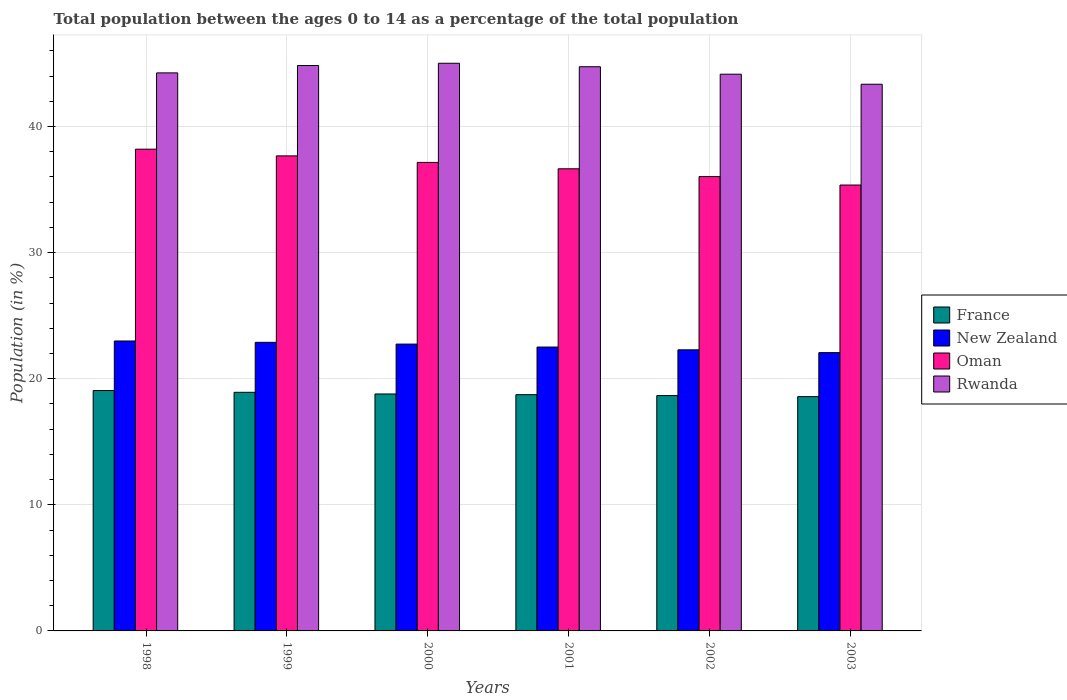How many different coloured bars are there?
Offer a terse response. 4. Are the number of bars on each tick of the X-axis equal?
Provide a succinct answer. Yes. What is the label of the 5th group of bars from the left?
Your response must be concise. 2002. What is the percentage of the population ages 0 to 14 in Oman in 1999?
Offer a very short reply. 37.67. Across all years, what is the maximum percentage of the population ages 0 to 14 in France?
Provide a short and direct response. 19.06. Across all years, what is the minimum percentage of the population ages 0 to 14 in France?
Keep it short and to the point. 18.58. In which year was the percentage of the population ages 0 to 14 in Oman maximum?
Make the answer very short. 1998. What is the total percentage of the population ages 0 to 14 in Rwanda in the graph?
Ensure brevity in your answer.  266.35. What is the difference between the percentage of the population ages 0 to 14 in France in 1998 and that in 2003?
Offer a terse response. 0.48. What is the difference between the percentage of the population ages 0 to 14 in New Zealand in 2000 and the percentage of the population ages 0 to 14 in France in 1998?
Provide a short and direct response. 3.68. What is the average percentage of the population ages 0 to 14 in France per year?
Provide a succinct answer. 18.79. In the year 2001, what is the difference between the percentage of the population ages 0 to 14 in New Zealand and percentage of the population ages 0 to 14 in France?
Offer a terse response. 3.77. What is the ratio of the percentage of the population ages 0 to 14 in France in 2002 to that in 2003?
Your answer should be very brief. 1. Is the difference between the percentage of the population ages 0 to 14 in New Zealand in 1998 and 2002 greater than the difference between the percentage of the population ages 0 to 14 in France in 1998 and 2002?
Your answer should be very brief. Yes. What is the difference between the highest and the second highest percentage of the population ages 0 to 14 in Rwanda?
Offer a terse response. 0.18. What is the difference between the highest and the lowest percentage of the population ages 0 to 14 in New Zealand?
Provide a short and direct response. 0.92. Is it the case that in every year, the sum of the percentage of the population ages 0 to 14 in Oman and percentage of the population ages 0 to 14 in Rwanda is greater than the sum of percentage of the population ages 0 to 14 in New Zealand and percentage of the population ages 0 to 14 in France?
Provide a short and direct response. Yes. What does the 1st bar from the left in 2000 represents?
Your response must be concise. France. What does the 3rd bar from the right in 2002 represents?
Offer a very short reply. New Zealand. Are all the bars in the graph horizontal?
Your answer should be compact. No. How many years are there in the graph?
Keep it short and to the point. 6. What is the difference between two consecutive major ticks on the Y-axis?
Offer a very short reply. 10. Are the values on the major ticks of Y-axis written in scientific E-notation?
Keep it short and to the point. No. Does the graph contain any zero values?
Provide a succinct answer. No. Does the graph contain grids?
Offer a very short reply. Yes. How many legend labels are there?
Provide a short and direct response. 4. What is the title of the graph?
Offer a terse response. Total population between the ages 0 to 14 as a percentage of the total population. What is the label or title of the X-axis?
Make the answer very short. Years. What is the label or title of the Y-axis?
Your response must be concise. Population (in %). What is the Population (in %) in France in 1998?
Provide a succinct answer. 19.06. What is the Population (in %) in New Zealand in 1998?
Provide a short and direct response. 22.99. What is the Population (in %) of Oman in 1998?
Your response must be concise. 38.2. What is the Population (in %) in Rwanda in 1998?
Provide a short and direct response. 44.25. What is the Population (in %) of France in 1999?
Your answer should be compact. 18.92. What is the Population (in %) of New Zealand in 1999?
Ensure brevity in your answer.  22.89. What is the Population (in %) of Oman in 1999?
Offer a very short reply. 37.67. What is the Population (in %) in Rwanda in 1999?
Your answer should be compact. 44.84. What is the Population (in %) in France in 2000?
Offer a very short reply. 18.79. What is the Population (in %) of New Zealand in 2000?
Provide a succinct answer. 22.75. What is the Population (in %) of Oman in 2000?
Provide a short and direct response. 37.15. What is the Population (in %) of Rwanda in 2000?
Your answer should be very brief. 45.02. What is the Population (in %) in France in 2001?
Provide a succinct answer. 18.74. What is the Population (in %) in New Zealand in 2001?
Your answer should be very brief. 22.51. What is the Population (in %) in Oman in 2001?
Your answer should be compact. 36.65. What is the Population (in %) in Rwanda in 2001?
Ensure brevity in your answer.  44.74. What is the Population (in %) in France in 2002?
Offer a very short reply. 18.66. What is the Population (in %) in New Zealand in 2002?
Keep it short and to the point. 22.29. What is the Population (in %) of Oman in 2002?
Keep it short and to the point. 36.03. What is the Population (in %) of Rwanda in 2002?
Provide a short and direct response. 44.15. What is the Population (in %) of France in 2003?
Your answer should be compact. 18.58. What is the Population (in %) in New Zealand in 2003?
Provide a short and direct response. 22.07. What is the Population (in %) in Oman in 2003?
Provide a short and direct response. 35.36. What is the Population (in %) in Rwanda in 2003?
Give a very brief answer. 43.35. Across all years, what is the maximum Population (in %) in France?
Ensure brevity in your answer.  19.06. Across all years, what is the maximum Population (in %) of New Zealand?
Your response must be concise. 22.99. Across all years, what is the maximum Population (in %) in Oman?
Your answer should be compact. 38.2. Across all years, what is the maximum Population (in %) of Rwanda?
Make the answer very short. 45.02. Across all years, what is the minimum Population (in %) of France?
Ensure brevity in your answer.  18.58. Across all years, what is the minimum Population (in %) of New Zealand?
Make the answer very short. 22.07. Across all years, what is the minimum Population (in %) in Oman?
Keep it short and to the point. 35.36. Across all years, what is the minimum Population (in %) of Rwanda?
Make the answer very short. 43.35. What is the total Population (in %) in France in the graph?
Give a very brief answer. 112.76. What is the total Population (in %) in New Zealand in the graph?
Your answer should be very brief. 135.49. What is the total Population (in %) of Oman in the graph?
Your answer should be compact. 221.07. What is the total Population (in %) in Rwanda in the graph?
Your answer should be compact. 266.35. What is the difference between the Population (in %) in France in 1998 and that in 1999?
Keep it short and to the point. 0.14. What is the difference between the Population (in %) of New Zealand in 1998 and that in 1999?
Your answer should be compact. 0.11. What is the difference between the Population (in %) in Oman in 1998 and that in 1999?
Ensure brevity in your answer.  0.53. What is the difference between the Population (in %) of Rwanda in 1998 and that in 1999?
Offer a terse response. -0.58. What is the difference between the Population (in %) in France in 1998 and that in 2000?
Your response must be concise. 0.27. What is the difference between the Population (in %) of New Zealand in 1998 and that in 2000?
Ensure brevity in your answer.  0.25. What is the difference between the Population (in %) in Oman in 1998 and that in 2000?
Ensure brevity in your answer.  1.05. What is the difference between the Population (in %) of Rwanda in 1998 and that in 2000?
Your answer should be compact. -0.76. What is the difference between the Population (in %) in France in 1998 and that in 2001?
Make the answer very short. 0.33. What is the difference between the Population (in %) of New Zealand in 1998 and that in 2001?
Provide a succinct answer. 0.48. What is the difference between the Population (in %) of Oman in 1998 and that in 2001?
Your response must be concise. 1.56. What is the difference between the Population (in %) in Rwanda in 1998 and that in 2001?
Ensure brevity in your answer.  -0.49. What is the difference between the Population (in %) of France in 1998 and that in 2002?
Provide a short and direct response. 0.4. What is the difference between the Population (in %) of New Zealand in 1998 and that in 2002?
Keep it short and to the point. 0.7. What is the difference between the Population (in %) of Oman in 1998 and that in 2002?
Offer a terse response. 2.17. What is the difference between the Population (in %) in Rwanda in 1998 and that in 2002?
Provide a succinct answer. 0.1. What is the difference between the Population (in %) of France in 1998 and that in 2003?
Offer a very short reply. 0.48. What is the difference between the Population (in %) of New Zealand in 1998 and that in 2003?
Give a very brief answer. 0.92. What is the difference between the Population (in %) in Oman in 1998 and that in 2003?
Offer a terse response. 2.84. What is the difference between the Population (in %) in Rwanda in 1998 and that in 2003?
Keep it short and to the point. 0.9. What is the difference between the Population (in %) in France in 1999 and that in 2000?
Give a very brief answer. 0.13. What is the difference between the Population (in %) in New Zealand in 1999 and that in 2000?
Your answer should be compact. 0.14. What is the difference between the Population (in %) of Oman in 1999 and that in 2000?
Ensure brevity in your answer.  0.52. What is the difference between the Population (in %) in Rwanda in 1999 and that in 2000?
Your answer should be very brief. -0.18. What is the difference between the Population (in %) in France in 1999 and that in 2001?
Ensure brevity in your answer.  0.19. What is the difference between the Population (in %) in New Zealand in 1999 and that in 2001?
Ensure brevity in your answer.  0.37. What is the difference between the Population (in %) of Oman in 1999 and that in 2001?
Give a very brief answer. 1.02. What is the difference between the Population (in %) in Rwanda in 1999 and that in 2001?
Offer a terse response. 0.09. What is the difference between the Population (in %) in France in 1999 and that in 2002?
Your response must be concise. 0.26. What is the difference between the Population (in %) of New Zealand in 1999 and that in 2002?
Your answer should be very brief. 0.59. What is the difference between the Population (in %) in Oman in 1999 and that in 2002?
Keep it short and to the point. 1.64. What is the difference between the Population (in %) in Rwanda in 1999 and that in 2002?
Give a very brief answer. 0.69. What is the difference between the Population (in %) of France in 1999 and that in 2003?
Make the answer very short. 0.34. What is the difference between the Population (in %) of New Zealand in 1999 and that in 2003?
Keep it short and to the point. 0.82. What is the difference between the Population (in %) in Oman in 1999 and that in 2003?
Your answer should be compact. 2.31. What is the difference between the Population (in %) of Rwanda in 1999 and that in 2003?
Provide a short and direct response. 1.48. What is the difference between the Population (in %) of France in 2000 and that in 2001?
Make the answer very short. 0.05. What is the difference between the Population (in %) in New Zealand in 2000 and that in 2001?
Your response must be concise. 0.23. What is the difference between the Population (in %) in Oman in 2000 and that in 2001?
Your answer should be very brief. 0.51. What is the difference between the Population (in %) of Rwanda in 2000 and that in 2001?
Your answer should be very brief. 0.28. What is the difference between the Population (in %) in France in 2000 and that in 2002?
Give a very brief answer. 0.13. What is the difference between the Population (in %) in New Zealand in 2000 and that in 2002?
Your answer should be compact. 0.45. What is the difference between the Population (in %) in Oman in 2000 and that in 2002?
Ensure brevity in your answer.  1.12. What is the difference between the Population (in %) in Rwanda in 2000 and that in 2002?
Offer a terse response. 0.87. What is the difference between the Population (in %) of France in 2000 and that in 2003?
Offer a terse response. 0.21. What is the difference between the Population (in %) in New Zealand in 2000 and that in 2003?
Your answer should be compact. 0.68. What is the difference between the Population (in %) in Oman in 2000 and that in 2003?
Offer a terse response. 1.79. What is the difference between the Population (in %) of Rwanda in 2000 and that in 2003?
Keep it short and to the point. 1.66. What is the difference between the Population (in %) in France in 2001 and that in 2002?
Ensure brevity in your answer.  0.07. What is the difference between the Population (in %) of New Zealand in 2001 and that in 2002?
Ensure brevity in your answer.  0.22. What is the difference between the Population (in %) of Oman in 2001 and that in 2002?
Give a very brief answer. 0.62. What is the difference between the Population (in %) in Rwanda in 2001 and that in 2002?
Provide a short and direct response. 0.59. What is the difference between the Population (in %) in France in 2001 and that in 2003?
Ensure brevity in your answer.  0.16. What is the difference between the Population (in %) of New Zealand in 2001 and that in 2003?
Keep it short and to the point. 0.44. What is the difference between the Population (in %) of Oman in 2001 and that in 2003?
Give a very brief answer. 1.29. What is the difference between the Population (in %) in Rwanda in 2001 and that in 2003?
Your answer should be very brief. 1.39. What is the difference between the Population (in %) of France in 2002 and that in 2003?
Keep it short and to the point. 0.08. What is the difference between the Population (in %) of New Zealand in 2002 and that in 2003?
Make the answer very short. 0.22. What is the difference between the Population (in %) of Oman in 2002 and that in 2003?
Your answer should be very brief. 0.67. What is the difference between the Population (in %) of Rwanda in 2002 and that in 2003?
Offer a very short reply. 0.8. What is the difference between the Population (in %) in France in 1998 and the Population (in %) in New Zealand in 1999?
Your answer should be compact. -3.82. What is the difference between the Population (in %) in France in 1998 and the Population (in %) in Oman in 1999?
Provide a succinct answer. -18.61. What is the difference between the Population (in %) in France in 1998 and the Population (in %) in Rwanda in 1999?
Offer a terse response. -25.77. What is the difference between the Population (in %) in New Zealand in 1998 and the Population (in %) in Oman in 1999?
Your response must be concise. -14.68. What is the difference between the Population (in %) in New Zealand in 1998 and the Population (in %) in Rwanda in 1999?
Offer a terse response. -21.84. What is the difference between the Population (in %) in Oman in 1998 and the Population (in %) in Rwanda in 1999?
Provide a succinct answer. -6.63. What is the difference between the Population (in %) of France in 1998 and the Population (in %) of New Zealand in 2000?
Offer a terse response. -3.68. What is the difference between the Population (in %) in France in 1998 and the Population (in %) in Oman in 2000?
Give a very brief answer. -18.09. What is the difference between the Population (in %) in France in 1998 and the Population (in %) in Rwanda in 2000?
Keep it short and to the point. -25.95. What is the difference between the Population (in %) of New Zealand in 1998 and the Population (in %) of Oman in 2000?
Give a very brief answer. -14.16. What is the difference between the Population (in %) of New Zealand in 1998 and the Population (in %) of Rwanda in 2000?
Offer a very short reply. -22.02. What is the difference between the Population (in %) of Oman in 1998 and the Population (in %) of Rwanda in 2000?
Ensure brevity in your answer.  -6.81. What is the difference between the Population (in %) of France in 1998 and the Population (in %) of New Zealand in 2001?
Make the answer very short. -3.45. What is the difference between the Population (in %) in France in 1998 and the Population (in %) in Oman in 2001?
Provide a succinct answer. -17.59. What is the difference between the Population (in %) in France in 1998 and the Population (in %) in Rwanda in 2001?
Give a very brief answer. -25.68. What is the difference between the Population (in %) of New Zealand in 1998 and the Population (in %) of Oman in 2001?
Offer a very short reply. -13.66. What is the difference between the Population (in %) in New Zealand in 1998 and the Population (in %) in Rwanda in 2001?
Offer a very short reply. -21.75. What is the difference between the Population (in %) of Oman in 1998 and the Population (in %) of Rwanda in 2001?
Your answer should be very brief. -6.54. What is the difference between the Population (in %) of France in 1998 and the Population (in %) of New Zealand in 2002?
Offer a terse response. -3.23. What is the difference between the Population (in %) in France in 1998 and the Population (in %) in Oman in 2002?
Your answer should be very brief. -16.97. What is the difference between the Population (in %) in France in 1998 and the Population (in %) in Rwanda in 2002?
Your answer should be compact. -25.09. What is the difference between the Population (in %) in New Zealand in 1998 and the Population (in %) in Oman in 2002?
Provide a succinct answer. -13.04. What is the difference between the Population (in %) of New Zealand in 1998 and the Population (in %) of Rwanda in 2002?
Provide a succinct answer. -21.16. What is the difference between the Population (in %) in Oman in 1998 and the Population (in %) in Rwanda in 2002?
Keep it short and to the point. -5.95. What is the difference between the Population (in %) in France in 1998 and the Population (in %) in New Zealand in 2003?
Your response must be concise. -3.01. What is the difference between the Population (in %) in France in 1998 and the Population (in %) in Oman in 2003?
Keep it short and to the point. -16.3. What is the difference between the Population (in %) of France in 1998 and the Population (in %) of Rwanda in 2003?
Offer a terse response. -24.29. What is the difference between the Population (in %) of New Zealand in 1998 and the Population (in %) of Oman in 2003?
Your answer should be compact. -12.37. What is the difference between the Population (in %) in New Zealand in 1998 and the Population (in %) in Rwanda in 2003?
Keep it short and to the point. -20.36. What is the difference between the Population (in %) of Oman in 1998 and the Population (in %) of Rwanda in 2003?
Give a very brief answer. -5.15. What is the difference between the Population (in %) in France in 1999 and the Population (in %) in New Zealand in 2000?
Ensure brevity in your answer.  -3.82. What is the difference between the Population (in %) in France in 1999 and the Population (in %) in Oman in 2000?
Give a very brief answer. -18.23. What is the difference between the Population (in %) in France in 1999 and the Population (in %) in Rwanda in 2000?
Provide a succinct answer. -26.09. What is the difference between the Population (in %) of New Zealand in 1999 and the Population (in %) of Oman in 2000?
Keep it short and to the point. -14.27. What is the difference between the Population (in %) in New Zealand in 1999 and the Population (in %) in Rwanda in 2000?
Provide a short and direct response. -22.13. What is the difference between the Population (in %) in Oman in 1999 and the Population (in %) in Rwanda in 2000?
Ensure brevity in your answer.  -7.35. What is the difference between the Population (in %) in France in 1999 and the Population (in %) in New Zealand in 2001?
Keep it short and to the point. -3.59. What is the difference between the Population (in %) in France in 1999 and the Population (in %) in Oman in 2001?
Your answer should be compact. -17.73. What is the difference between the Population (in %) of France in 1999 and the Population (in %) of Rwanda in 2001?
Provide a short and direct response. -25.82. What is the difference between the Population (in %) of New Zealand in 1999 and the Population (in %) of Oman in 2001?
Your answer should be compact. -13.76. What is the difference between the Population (in %) of New Zealand in 1999 and the Population (in %) of Rwanda in 2001?
Keep it short and to the point. -21.86. What is the difference between the Population (in %) of Oman in 1999 and the Population (in %) of Rwanda in 2001?
Make the answer very short. -7.07. What is the difference between the Population (in %) in France in 1999 and the Population (in %) in New Zealand in 2002?
Make the answer very short. -3.37. What is the difference between the Population (in %) of France in 1999 and the Population (in %) of Oman in 2002?
Your response must be concise. -17.11. What is the difference between the Population (in %) in France in 1999 and the Population (in %) in Rwanda in 2002?
Provide a short and direct response. -25.23. What is the difference between the Population (in %) in New Zealand in 1999 and the Population (in %) in Oman in 2002?
Offer a very short reply. -13.15. What is the difference between the Population (in %) of New Zealand in 1999 and the Population (in %) of Rwanda in 2002?
Keep it short and to the point. -21.26. What is the difference between the Population (in %) in Oman in 1999 and the Population (in %) in Rwanda in 2002?
Offer a terse response. -6.48. What is the difference between the Population (in %) in France in 1999 and the Population (in %) in New Zealand in 2003?
Your answer should be very brief. -3.15. What is the difference between the Population (in %) of France in 1999 and the Population (in %) of Oman in 2003?
Your answer should be very brief. -16.44. What is the difference between the Population (in %) of France in 1999 and the Population (in %) of Rwanda in 2003?
Your answer should be very brief. -24.43. What is the difference between the Population (in %) in New Zealand in 1999 and the Population (in %) in Oman in 2003?
Provide a short and direct response. -12.47. What is the difference between the Population (in %) of New Zealand in 1999 and the Population (in %) of Rwanda in 2003?
Give a very brief answer. -20.47. What is the difference between the Population (in %) of Oman in 1999 and the Population (in %) of Rwanda in 2003?
Ensure brevity in your answer.  -5.68. What is the difference between the Population (in %) of France in 2000 and the Population (in %) of New Zealand in 2001?
Give a very brief answer. -3.72. What is the difference between the Population (in %) in France in 2000 and the Population (in %) in Oman in 2001?
Your answer should be compact. -17.86. What is the difference between the Population (in %) of France in 2000 and the Population (in %) of Rwanda in 2001?
Provide a short and direct response. -25.95. What is the difference between the Population (in %) of New Zealand in 2000 and the Population (in %) of Oman in 2001?
Give a very brief answer. -13.9. What is the difference between the Population (in %) of New Zealand in 2000 and the Population (in %) of Rwanda in 2001?
Provide a succinct answer. -22. What is the difference between the Population (in %) of Oman in 2000 and the Population (in %) of Rwanda in 2001?
Keep it short and to the point. -7.59. What is the difference between the Population (in %) of France in 2000 and the Population (in %) of New Zealand in 2002?
Keep it short and to the point. -3.5. What is the difference between the Population (in %) of France in 2000 and the Population (in %) of Oman in 2002?
Your answer should be very brief. -17.24. What is the difference between the Population (in %) in France in 2000 and the Population (in %) in Rwanda in 2002?
Your answer should be compact. -25.36. What is the difference between the Population (in %) in New Zealand in 2000 and the Population (in %) in Oman in 2002?
Your response must be concise. -13.29. What is the difference between the Population (in %) in New Zealand in 2000 and the Population (in %) in Rwanda in 2002?
Keep it short and to the point. -21.4. What is the difference between the Population (in %) of Oman in 2000 and the Population (in %) of Rwanda in 2002?
Give a very brief answer. -7. What is the difference between the Population (in %) in France in 2000 and the Population (in %) in New Zealand in 2003?
Offer a very short reply. -3.28. What is the difference between the Population (in %) in France in 2000 and the Population (in %) in Oman in 2003?
Provide a succinct answer. -16.57. What is the difference between the Population (in %) of France in 2000 and the Population (in %) of Rwanda in 2003?
Your answer should be compact. -24.56. What is the difference between the Population (in %) in New Zealand in 2000 and the Population (in %) in Oman in 2003?
Provide a short and direct response. -12.61. What is the difference between the Population (in %) in New Zealand in 2000 and the Population (in %) in Rwanda in 2003?
Give a very brief answer. -20.61. What is the difference between the Population (in %) in Oman in 2000 and the Population (in %) in Rwanda in 2003?
Offer a terse response. -6.2. What is the difference between the Population (in %) of France in 2001 and the Population (in %) of New Zealand in 2002?
Your answer should be compact. -3.56. What is the difference between the Population (in %) in France in 2001 and the Population (in %) in Oman in 2002?
Provide a succinct answer. -17.29. What is the difference between the Population (in %) of France in 2001 and the Population (in %) of Rwanda in 2002?
Make the answer very short. -25.41. What is the difference between the Population (in %) in New Zealand in 2001 and the Population (in %) in Oman in 2002?
Offer a terse response. -13.52. What is the difference between the Population (in %) of New Zealand in 2001 and the Population (in %) of Rwanda in 2002?
Your answer should be compact. -21.64. What is the difference between the Population (in %) in Oman in 2001 and the Population (in %) in Rwanda in 2002?
Offer a terse response. -7.5. What is the difference between the Population (in %) in France in 2001 and the Population (in %) in New Zealand in 2003?
Your answer should be very brief. -3.33. What is the difference between the Population (in %) in France in 2001 and the Population (in %) in Oman in 2003?
Make the answer very short. -16.62. What is the difference between the Population (in %) in France in 2001 and the Population (in %) in Rwanda in 2003?
Offer a terse response. -24.62. What is the difference between the Population (in %) in New Zealand in 2001 and the Population (in %) in Oman in 2003?
Your answer should be compact. -12.85. What is the difference between the Population (in %) of New Zealand in 2001 and the Population (in %) of Rwanda in 2003?
Offer a very short reply. -20.84. What is the difference between the Population (in %) of Oman in 2001 and the Population (in %) of Rwanda in 2003?
Provide a short and direct response. -6.7. What is the difference between the Population (in %) in France in 2002 and the Population (in %) in New Zealand in 2003?
Your response must be concise. -3.41. What is the difference between the Population (in %) of France in 2002 and the Population (in %) of Oman in 2003?
Your response must be concise. -16.7. What is the difference between the Population (in %) of France in 2002 and the Population (in %) of Rwanda in 2003?
Your answer should be compact. -24.69. What is the difference between the Population (in %) in New Zealand in 2002 and the Population (in %) in Oman in 2003?
Keep it short and to the point. -13.07. What is the difference between the Population (in %) of New Zealand in 2002 and the Population (in %) of Rwanda in 2003?
Keep it short and to the point. -21.06. What is the difference between the Population (in %) of Oman in 2002 and the Population (in %) of Rwanda in 2003?
Offer a terse response. -7.32. What is the average Population (in %) of France per year?
Make the answer very short. 18.79. What is the average Population (in %) in New Zealand per year?
Provide a short and direct response. 22.58. What is the average Population (in %) of Oman per year?
Offer a terse response. 36.84. What is the average Population (in %) of Rwanda per year?
Make the answer very short. 44.39. In the year 1998, what is the difference between the Population (in %) in France and Population (in %) in New Zealand?
Your answer should be compact. -3.93. In the year 1998, what is the difference between the Population (in %) in France and Population (in %) in Oman?
Make the answer very short. -19.14. In the year 1998, what is the difference between the Population (in %) of France and Population (in %) of Rwanda?
Make the answer very short. -25.19. In the year 1998, what is the difference between the Population (in %) of New Zealand and Population (in %) of Oman?
Make the answer very short. -15.21. In the year 1998, what is the difference between the Population (in %) in New Zealand and Population (in %) in Rwanda?
Keep it short and to the point. -21.26. In the year 1998, what is the difference between the Population (in %) of Oman and Population (in %) of Rwanda?
Your answer should be compact. -6.05. In the year 1999, what is the difference between the Population (in %) in France and Population (in %) in New Zealand?
Provide a succinct answer. -3.96. In the year 1999, what is the difference between the Population (in %) of France and Population (in %) of Oman?
Your response must be concise. -18.75. In the year 1999, what is the difference between the Population (in %) in France and Population (in %) in Rwanda?
Provide a succinct answer. -25.91. In the year 1999, what is the difference between the Population (in %) of New Zealand and Population (in %) of Oman?
Offer a very short reply. -14.79. In the year 1999, what is the difference between the Population (in %) of New Zealand and Population (in %) of Rwanda?
Your answer should be very brief. -21.95. In the year 1999, what is the difference between the Population (in %) in Oman and Population (in %) in Rwanda?
Keep it short and to the point. -7.17. In the year 2000, what is the difference between the Population (in %) of France and Population (in %) of New Zealand?
Your answer should be compact. -3.96. In the year 2000, what is the difference between the Population (in %) of France and Population (in %) of Oman?
Give a very brief answer. -18.36. In the year 2000, what is the difference between the Population (in %) of France and Population (in %) of Rwanda?
Your answer should be very brief. -26.23. In the year 2000, what is the difference between the Population (in %) of New Zealand and Population (in %) of Oman?
Your answer should be compact. -14.41. In the year 2000, what is the difference between the Population (in %) of New Zealand and Population (in %) of Rwanda?
Keep it short and to the point. -22.27. In the year 2000, what is the difference between the Population (in %) of Oman and Population (in %) of Rwanda?
Offer a very short reply. -7.86. In the year 2001, what is the difference between the Population (in %) of France and Population (in %) of New Zealand?
Your answer should be compact. -3.77. In the year 2001, what is the difference between the Population (in %) of France and Population (in %) of Oman?
Offer a very short reply. -17.91. In the year 2001, what is the difference between the Population (in %) of France and Population (in %) of Rwanda?
Your answer should be very brief. -26.01. In the year 2001, what is the difference between the Population (in %) of New Zealand and Population (in %) of Oman?
Offer a terse response. -14.14. In the year 2001, what is the difference between the Population (in %) in New Zealand and Population (in %) in Rwanda?
Ensure brevity in your answer.  -22.23. In the year 2001, what is the difference between the Population (in %) in Oman and Population (in %) in Rwanda?
Offer a very short reply. -8.09. In the year 2002, what is the difference between the Population (in %) in France and Population (in %) in New Zealand?
Your response must be concise. -3.63. In the year 2002, what is the difference between the Population (in %) in France and Population (in %) in Oman?
Your answer should be compact. -17.37. In the year 2002, what is the difference between the Population (in %) in France and Population (in %) in Rwanda?
Your answer should be compact. -25.49. In the year 2002, what is the difference between the Population (in %) of New Zealand and Population (in %) of Oman?
Ensure brevity in your answer.  -13.74. In the year 2002, what is the difference between the Population (in %) in New Zealand and Population (in %) in Rwanda?
Provide a short and direct response. -21.86. In the year 2002, what is the difference between the Population (in %) of Oman and Population (in %) of Rwanda?
Give a very brief answer. -8.12. In the year 2003, what is the difference between the Population (in %) of France and Population (in %) of New Zealand?
Offer a very short reply. -3.49. In the year 2003, what is the difference between the Population (in %) in France and Population (in %) in Oman?
Offer a terse response. -16.78. In the year 2003, what is the difference between the Population (in %) in France and Population (in %) in Rwanda?
Your answer should be very brief. -24.77. In the year 2003, what is the difference between the Population (in %) of New Zealand and Population (in %) of Oman?
Make the answer very short. -13.29. In the year 2003, what is the difference between the Population (in %) of New Zealand and Population (in %) of Rwanda?
Keep it short and to the point. -21.28. In the year 2003, what is the difference between the Population (in %) of Oman and Population (in %) of Rwanda?
Give a very brief answer. -7.99. What is the ratio of the Population (in %) in France in 1998 to that in 1999?
Your answer should be compact. 1.01. What is the ratio of the Population (in %) of New Zealand in 1998 to that in 1999?
Offer a terse response. 1. What is the ratio of the Population (in %) of Oman in 1998 to that in 1999?
Offer a very short reply. 1.01. What is the ratio of the Population (in %) in France in 1998 to that in 2000?
Give a very brief answer. 1.01. What is the ratio of the Population (in %) in New Zealand in 1998 to that in 2000?
Ensure brevity in your answer.  1.01. What is the ratio of the Population (in %) of Oman in 1998 to that in 2000?
Your response must be concise. 1.03. What is the ratio of the Population (in %) in Rwanda in 1998 to that in 2000?
Ensure brevity in your answer.  0.98. What is the ratio of the Population (in %) of France in 1998 to that in 2001?
Your answer should be very brief. 1.02. What is the ratio of the Population (in %) of New Zealand in 1998 to that in 2001?
Your response must be concise. 1.02. What is the ratio of the Population (in %) of Oman in 1998 to that in 2001?
Provide a succinct answer. 1.04. What is the ratio of the Population (in %) in France in 1998 to that in 2002?
Your answer should be very brief. 1.02. What is the ratio of the Population (in %) in New Zealand in 1998 to that in 2002?
Your answer should be compact. 1.03. What is the ratio of the Population (in %) of Oman in 1998 to that in 2002?
Your response must be concise. 1.06. What is the ratio of the Population (in %) of France in 1998 to that in 2003?
Make the answer very short. 1.03. What is the ratio of the Population (in %) of New Zealand in 1998 to that in 2003?
Your answer should be very brief. 1.04. What is the ratio of the Population (in %) of Oman in 1998 to that in 2003?
Provide a succinct answer. 1.08. What is the ratio of the Population (in %) of Rwanda in 1998 to that in 2003?
Make the answer very short. 1.02. What is the ratio of the Population (in %) in France in 1999 to that in 2000?
Give a very brief answer. 1.01. What is the ratio of the Population (in %) of New Zealand in 1999 to that in 2000?
Your response must be concise. 1.01. What is the ratio of the Population (in %) in Oman in 1999 to that in 2000?
Give a very brief answer. 1.01. What is the ratio of the Population (in %) of New Zealand in 1999 to that in 2001?
Ensure brevity in your answer.  1.02. What is the ratio of the Population (in %) of Oman in 1999 to that in 2001?
Offer a terse response. 1.03. What is the ratio of the Population (in %) of Rwanda in 1999 to that in 2001?
Offer a very short reply. 1. What is the ratio of the Population (in %) in France in 1999 to that in 2002?
Offer a very short reply. 1.01. What is the ratio of the Population (in %) in New Zealand in 1999 to that in 2002?
Your answer should be very brief. 1.03. What is the ratio of the Population (in %) of Oman in 1999 to that in 2002?
Offer a very short reply. 1.05. What is the ratio of the Population (in %) in Rwanda in 1999 to that in 2002?
Your answer should be compact. 1.02. What is the ratio of the Population (in %) in France in 1999 to that in 2003?
Offer a terse response. 1.02. What is the ratio of the Population (in %) in Oman in 1999 to that in 2003?
Provide a succinct answer. 1.07. What is the ratio of the Population (in %) in Rwanda in 1999 to that in 2003?
Offer a very short reply. 1.03. What is the ratio of the Population (in %) of New Zealand in 2000 to that in 2001?
Offer a very short reply. 1.01. What is the ratio of the Population (in %) of Oman in 2000 to that in 2001?
Offer a very short reply. 1.01. What is the ratio of the Population (in %) in New Zealand in 2000 to that in 2002?
Offer a very short reply. 1.02. What is the ratio of the Population (in %) of Oman in 2000 to that in 2002?
Give a very brief answer. 1.03. What is the ratio of the Population (in %) in Rwanda in 2000 to that in 2002?
Offer a terse response. 1.02. What is the ratio of the Population (in %) in France in 2000 to that in 2003?
Provide a short and direct response. 1.01. What is the ratio of the Population (in %) in New Zealand in 2000 to that in 2003?
Offer a very short reply. 1.03. What is the ratio of the Population (in %) in Oman in 2000 to that in 2003?
Your answer should be very brief. 1.05. What is the ratio of the Population (in %) of Rwanda in 2000 to that in 2003?
Provide a short and direct response. 1.04. What is the ratio of the Population (in %) in France in 2001 to that in 2002?
Offer a very short reply. 1. What is the ratio of the Population (in %) of New Zealand in 2001 to that in 2002?
Your answer should be very brief. 1.01. What is the ratio of the Population (in %) of Oman in 2001 to that in 2002?
Offer a very short reply. 1.02. What is the ratio of the Population (in %) of Rwanda in 2001 to that in 2002?
Provide a short and direct response. 1.01. What is the ratio of the Population (in %) of France in 2001 to that in 2003?
Ensure brevity in your answer.  1.01. What is the ratio of the Population (in %) of Oman in 2001 to that in 2003?
Provide a short and direct response. 1.04. What is the ratio of the Population (in %) of Rwanda in 2001 to that in 2003?
Offer a terse response. 1.03. What is the ratio of the Population (in %) of Rwanda in 2002 to that in 2003?
Your answer should be compact. 1.02. What is the difference between the highest and the second highest Population (in %) of France?
Give a very brief answer. 0.14. What is the difference between the highest and the second highest Population (in %) in New Zealand?
Provide a short and direct response. 0.11. What is the difference between the highest and the second highest Population (in %) of Oman?
Provide a short and direct response. 0.53. What is the difference between the highest and the second highest Population (in %) in Rwanda?
Keep it short and to the point. 0.18. What is the difference between the highest and the lowest Population (in %) of France?
Offer a terse response. 0.48. What is the difference between the highest and the lowest Population (in %) of New Zealand?
Your answer should be very brief. 0.92. What is the difference between the highest and the lowest Population (in %) of Oman?
Give a very brief answer. 2.84. What is the difference between the highest and the lowest Population (in %) in Rwanda?
Provide a succinct answer. 1.66. 